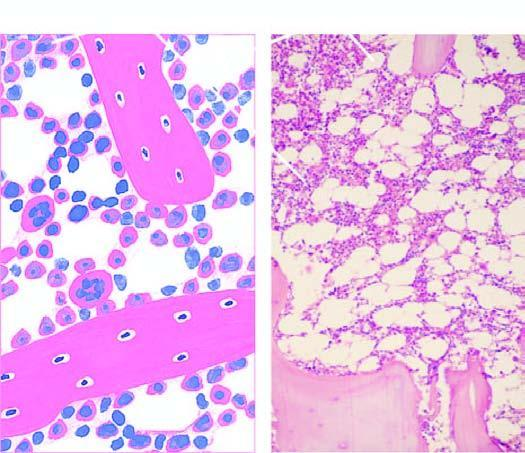how many percent of the soft tissue of the bone consists of haematopoietic tissue?
Answer the question using a single word or phrase. Approximately 50% 